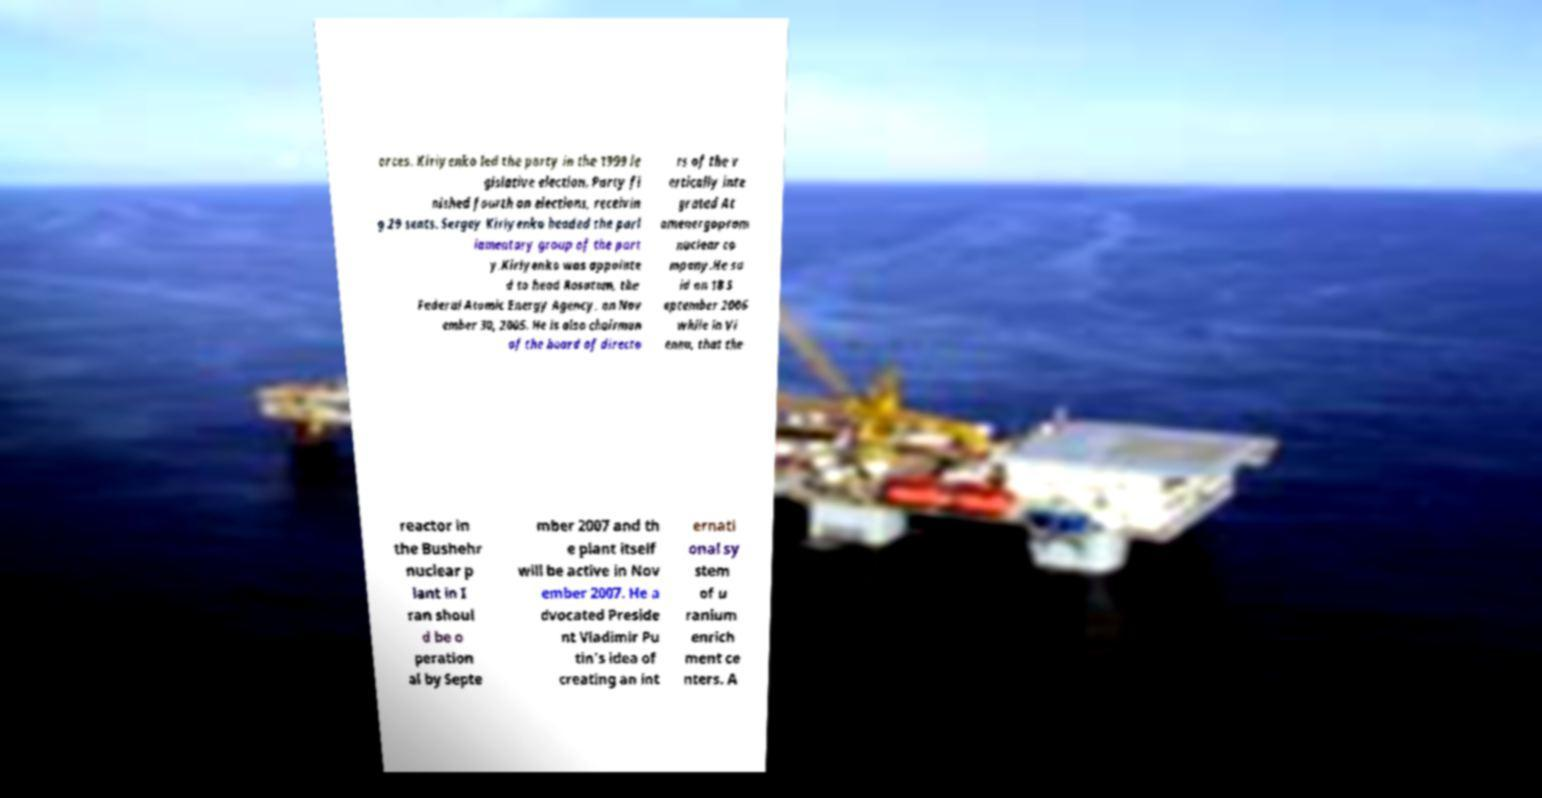Please identify and transcribe the text found in this image. orces. Kiriyenko led the party in the 1999 le gislative election. Party fi nished fourth on elections, receivin g 29 seats. Sergey Kiriyenko headed the parl iamentary group of the part y.Kiriyenko was appointe d to head Rosatom, the Federal Atomic Energy Agency, on Nov ember 30, 2005. He is also chairman of the board of directo rs of the v ertically inte grated At omenergoprom nuclear co mpany.He sa id on 18 S eptember 2006 while in Vi enna, that the reactor in the Bushehr nuclear p lant in I ran shoul d be o peration al by Septe mber 2007 and th e plant itself will be active in Nov ember 2007. He a dvocated Preside nt Vladimir Pu tin's idea of creating an int ernati onal sy stem of u ranium enrich ment ce nters. A 